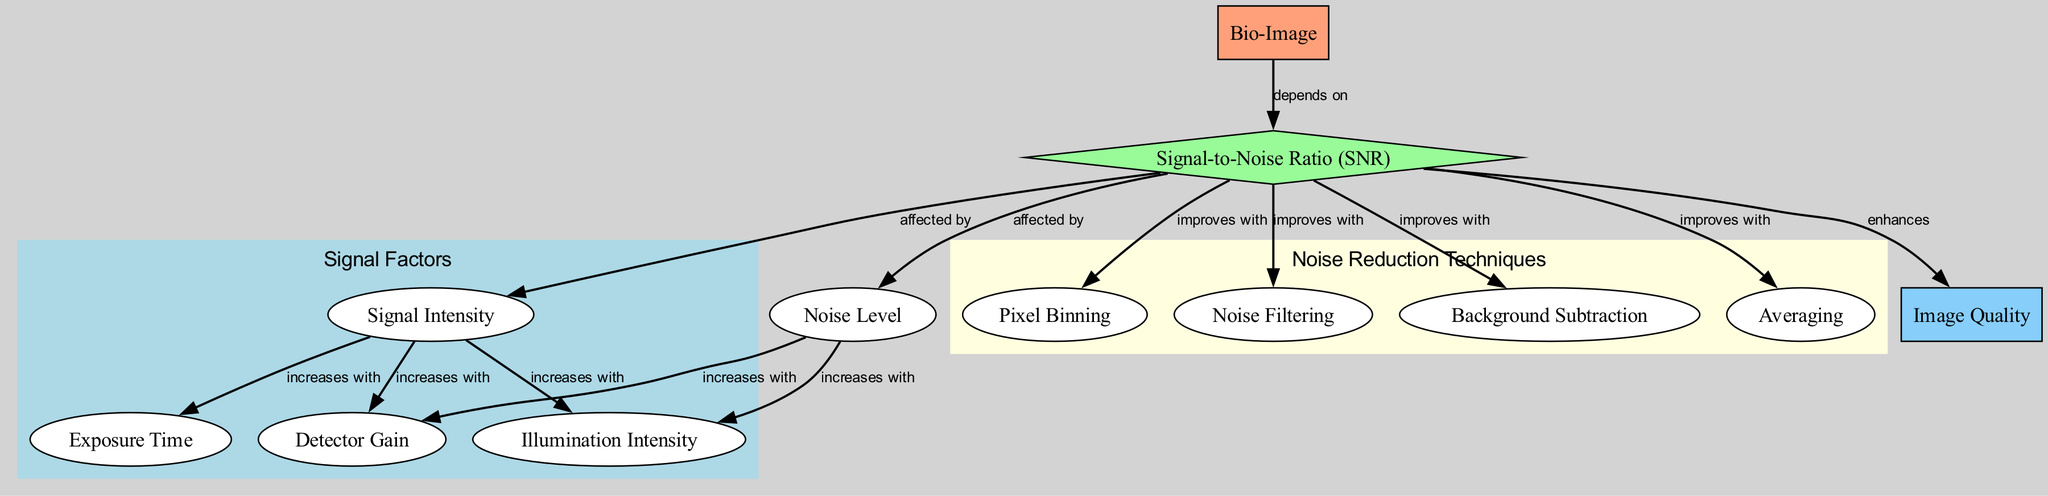What is the relationship between the bio-image and the signal-to-noise ratio? The bio-image depends on the signal-to-noise ratio as indicated by the directed edge labeled "depends on." This shows that the quality and characteristics of the bio-image are influenced by the SNR.
Answer: depends on How many nodes are in the diagram? Counting the nodes listed in the diagram, there are a total of 12 nodes representing various aspects related to SNR and imaging.
Answer: 12 What factors increase signal intensity? Signal intensity is increased by illumination intensity, exposure time, and detector gain as represented by the three edges pointing towards the signal intensity node.
Answer: illumination intensity, exposure time, detector gain Which technique improves signal-to-noise ratio the most? Each of the techniques listed—pixel binning, filtering, background subtraction, and averaging—improves the signal-to-noise ratio. However, the diagram does not specify which one is most effective, so a definitive answer cannot be determined from the diagram alone.
Answer: Not specified What happens to noise level as illumination intensity increases? The noise level increases with illumination intensity according to the directed edge labeled "increases with," indicating that boosting illumination may elevate the amount of noise in the system.
Answer: increases Which node enhances image quality? The signal-to-noise ratio enhances image quality, as represented by the edge labeled "enhances." This indicates a direct impact of improving SNR on the overall quality of the image obtained.
Answer: enhances What effect does pixel binning have on signal-to-noise ratio? Pixel binning improves the signal-to-noise ratio according to the directed edge labeled "improves with," suggesting that implementing pixel binning can yield better SNR.
Answer: improves How does detector gain relate to noise level? The noise level increases with detector gain, as indicated by the edge labeled "increases with." This shows that increasing the gain of the detector could inadvertently lead to a rise in noise levels.
Answer: increases with What is the most significant dependence of the signal-to-noise ratio? The signal-to-noise ratio is significantly affected by both signal intensity and noise level, as represented by the two edges that indicate they affect the SNR.
Answer: signal intensity and noise level 